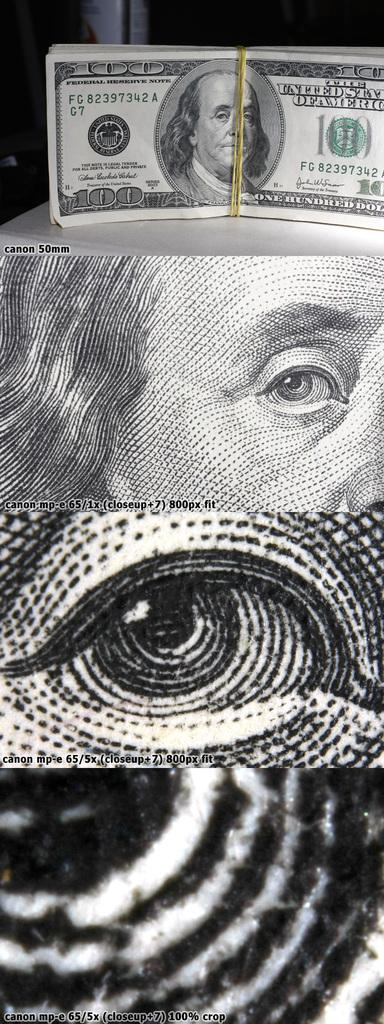What is the color scheme of the image? The image is black and white. What type of image is it? The image is an edited picture. Who is depicted in the image? Benjamin Franklin is depicted in the image. What is Benjamin Franklin's association with the 100 dollar note? Benjamin Franklin is on a 100 dollar note. Which part of Benjamin Franklin's face is visible in the image? The eye of Benjamin Franklin is visible in the image. What type of can is shown in the image? There is no can present in the image; it features Benjamin Franklin. What type of lawyer is depicted in the image? The image does not depict a lawyer; it features Benjamin Franklin, who was a statesman and inventor. 